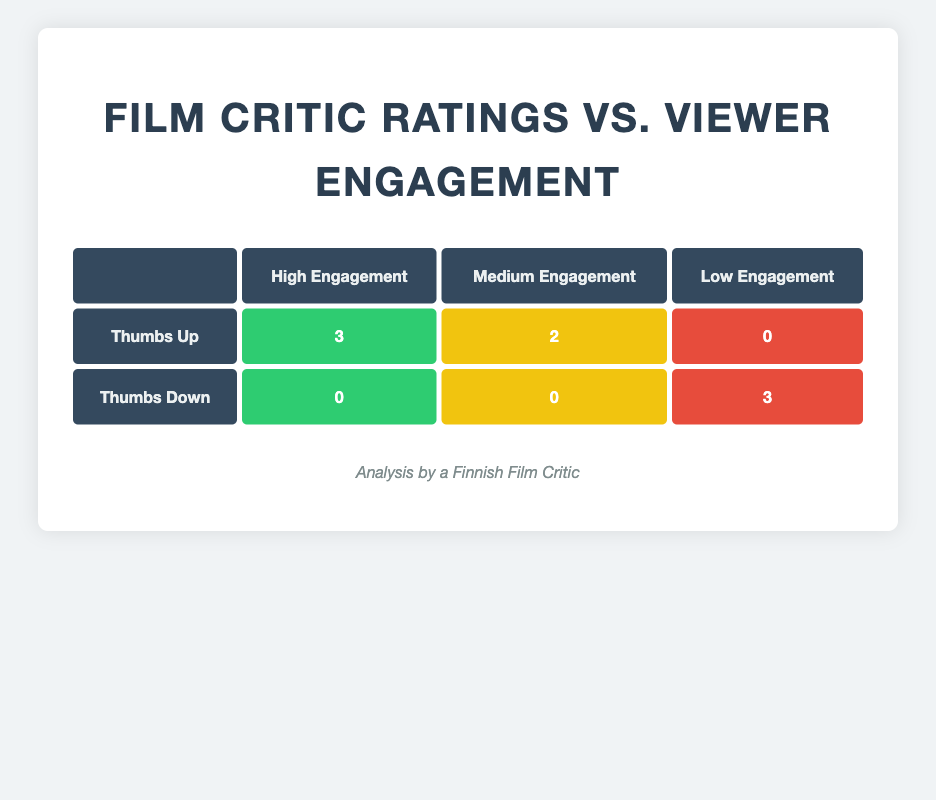What is the count of films that received a Thumbs Up and have High Engagement? The table shows that there are 3 films with Thumbs Up and High Engagement (The Man from the North, Whispers of the Heart, Voices in the Wind).
Answer: 3 How many films received a Thumbs Down rating? The table shows there are 3 films in the Thumbs Down category (Shadows of Dawn, The Last Train Home, Through the Flames).
Answer: 3 Is it true that all films with Thumbs Down also have Low Engagement? The table lists 3 films with Thumbs Down, all of them (Shadows of Dawn, The Last Train Home, Through the Flames) have Low Engagement.
Answer: Yes What is the total number of films with Medium Engagement? The table shows there are 2 films with Thumbs Up that have Medium Engagement (The Lost Journey, Echoes of Silence) and no films with Thumbs Down have Medium Engagement, summing up gives us 2.
Answer: 2 How does the viewer engagement of films rated with Thumbs Up compare to those rated with Thumbs Down? For Thumbs Up, there are 3 films with High Engagement, 2 with Medium, and 0 with Low. For Thumbs Down, there are 0 films with High Engagement, 0 with Medium, and 3 with Low. The Thumbs Up films have higher viewer engagement as there are no High or Medium Engagement for Thumbs Down films.
Answer: Thumbs Up films have higher engagement What is the difference in the number of films between High Engagement and Low Engagement? In the High Engagement category, there are 3 films with Thumbs Up and no films with Thumbs Down, giving a total of 3 films. In the Low Engagement category, there are 3 films with Thumbs Down and no films with Thumbs Up, also totaling 3 films. Thus the difference is 3 - 3 = 0.
Answer: 0 